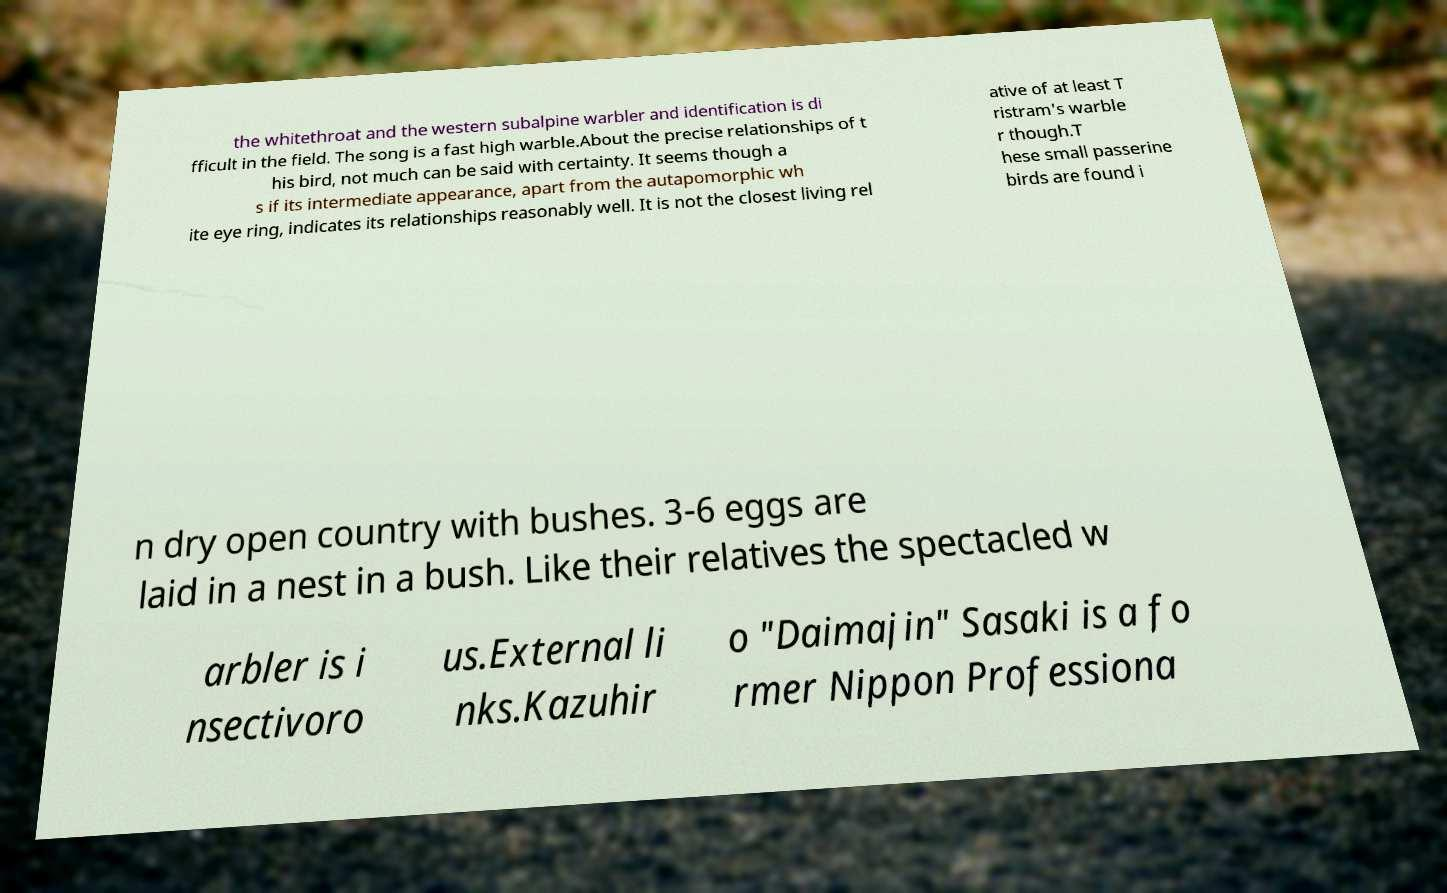I need the written content from this picture converted into text. Can you do that? the whitethroat and the western subalpine warbler and identification is di fficult in the field. The song is a fast high warble.About the precise relationships of t his bird, not much can be said with certainty. It seems though a s if its intermediate appearance, apart from the autapomorphic wh ite eye ring, indicates its relationships reasonably well. It is not the closest living rel ative of at least T ristram's warble r though.T hese small passerine birds are found i n dry open country with bushes. 3-6 eggs are laid in a nest in a bush. Like their relatives the spectacled w arbler is i nsectivoro us.External li nks.Kazuhir o "Daimajin" Sasaki is a fo rmer Nippon Professiona 